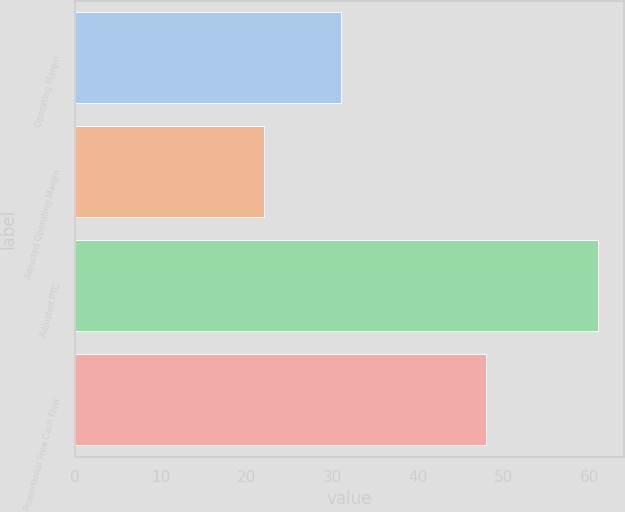Convert chart. <chart><loc_0><loc_0><loc_500><loc_500><bar_chart><fcel>Operating Margin<fcel>Adjusted Operating Margin<fcel>Adjusted PTC<fcel>Proportional Free Cash Flow<nl><fcel>31<fcel>22<fcel>61<fcel>48<nl></chart> 